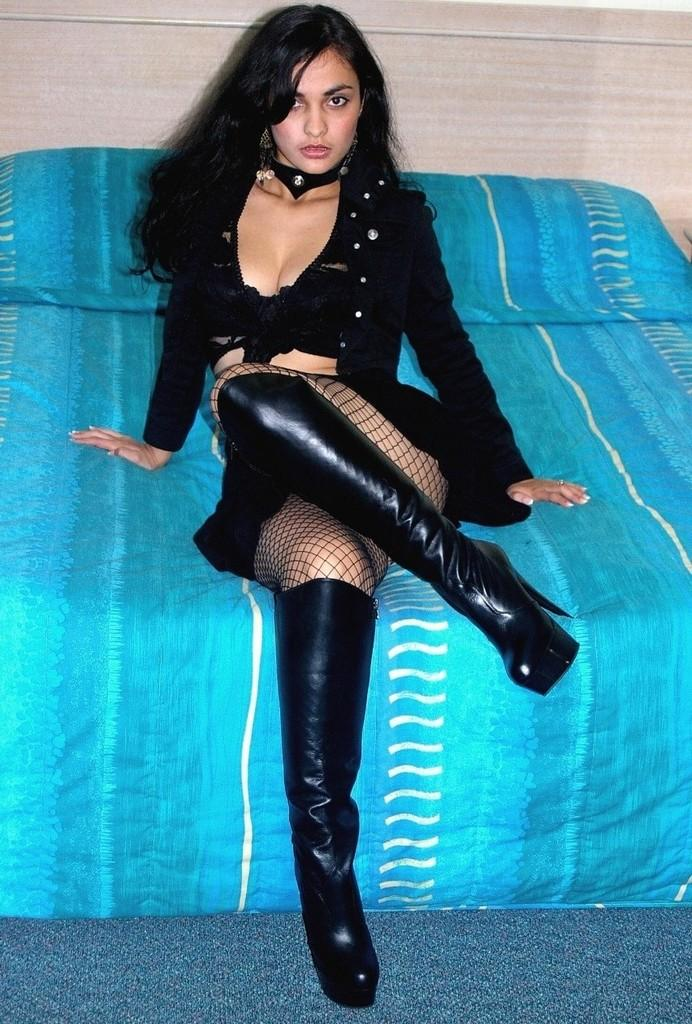Who is the main subject in the image? There is a lady in the image. What type of footwear is the lady wearing? The lady is wearing boots. What is the lady doing in the image? The lady is sitting on a bed. What can be seen in the background of the image? There is a wall in the background of the image. What type of tank is visible in the image? There is no tank present in the image. What facial expression does the lady have in the image? The image does not show the lady's face, so her facial expression cannot be determined. What type of legal authority is present in the image? There is no legal authority, such as a judge, present in the image. 